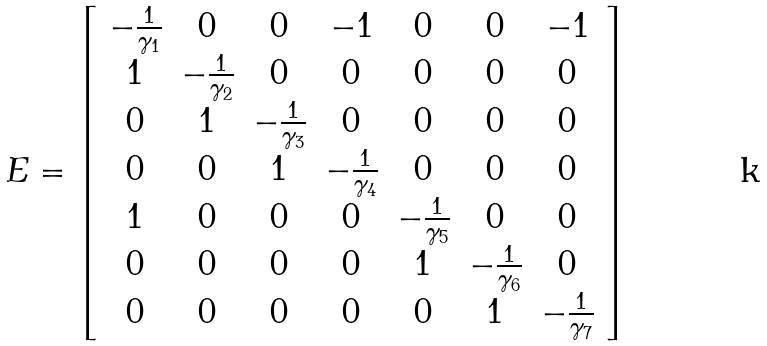<formula> <loc_0><loc_0><loc_500><loc_500>E = \left [ \begin{array} { c c c c c c c } - \frac { 1 } { \gamma _ { 1 } } & 0 & 0 & - 1 & 0 & 0 & - 1 \\ 1 & - \frac { 1 } { \gamma _ { 2 } } & 0 & 0 & 0 & 0 & 0 \\ 0 & 1 & - \frac { 1 } { \gamma _ { 3 } } & 0 & 0 & 0 & 0 \\ 0 & 0 & 1 & - \frac { 1 } { \gamma _ { 4 } } & 0 & 0 & 0 \\ 1 & 0 & 0 & 0 & - \frac { 1 } { \gamma _ { 5 } } & 0 & 0 \\ 0 & 0 & 0 & 0 & 1 & - \frac { 1 } { \gamma _ { 6 } } & 0 \\ 0 & 0 & 0 & 0 & 0 & 1 & - \frac { 1 } { \gamma _ { 7 } } \end{array} \right ]</formula> 